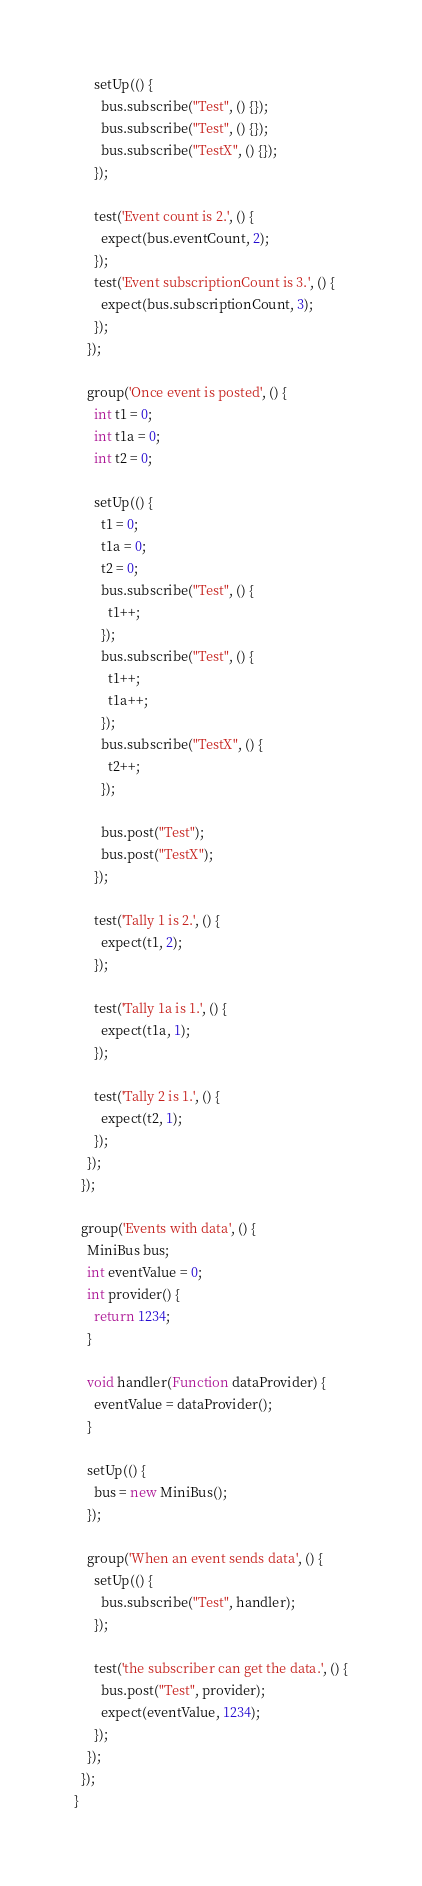Convert code to text. <code><loc_0><loc_0><loc_500><loc_500><_Dart_>      setUp(() {
        bus.subscribe("Test", () {});
        bus.subscribe("Test", () {});
        bus.subscribe("TestX", () {});
      });

      test('Event count is 2.', () {
        expect(bus.eventCount, 2);
      });
      test('Event subscriptionCount is 3.', () {
        expect(bus.subscriptionCount, 3);
      });
    });

    group('Once event is posted', () {
      int t1 = 0;
      int t1a = 0;
      int t2 = 0;

      setUp(() {
        t1 = 0;
        t1a = 0;
        t2 = 0;
        bus.subscribe("Test", () {
          t1++;
        });
        bus.subscribe("Test", () {
          t1++;
          t1a++;
        });
        bus.subscribe("TestX", () {
          t2++;
        });

        bus.post("Test");
        bus.post("TestX");
      });

      test('Tally 1 is 2.', () {
        expect(t1, 2);
      });

      test('Tally 1a is 1.', () {
        expect(t1a, 1);
      });

      test('Tally 2 is 1.', () {
        expect(t2, 1);
      });
    });
  });

  group('Events with data', () {
    MiniBus bus;
    int eventValue = 0;
    int provider() {
      return 1234;
    }

    void handler(Function dataProvider) {
      eventValue = dataProvider();
    }

    setUp(() {
      bus = new MiniBus();
    });

    group('When an event sends data', () {
      setUp(() {
        bus.subscribe("Test", handler);
      });

      test('the subscriber can get the data.', () {
        bus.post("Test", provider);
        expect(eventValue, 1234);
      });
    });
  });
}
</code> 